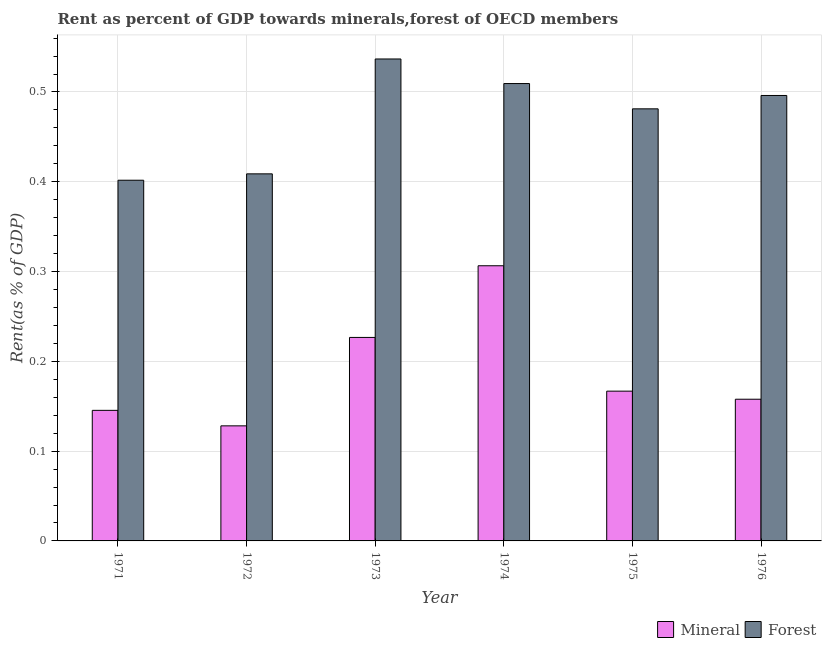How many different coloured bars are there?
Give a very brief answer. 2. Are the number of bars on each tick of the X-axis equal?
Provide a short and direct response. Yes. How many bars are there on the 2nd tick from the right?
Make the answer very short. 2. What is the label of the 5th group of bars from the left?
Your response must be concise. 1975. What is the mineral rent in 1971?
Keep it short and to the point. 0.15. Across all years, what is the maximum mineral rent?
Offer a very short reply. 0.31. Across all years, what is the minimum mineral rent?
Ensure brevity in your answer.  0.13. In which year was the mineral rent maximum?
Your response must be concise. 1974. What is the total mineral rent in the graph?
Provide a succinct answer. 1.13. What is the difference between the forest rent in 1973 and that in 1975?
Provide a short and direct response. 0.06. What is the difference between the forest rent in 1972 and the mineral rent in 1976?
Make the answer very short. -0.09. What is the average forest rent per year?
Ensure brevity in your answer.  0.47. In the year 1975, what is the difference between the forest rent and mineral rent?
Provide a short and direct response. 0. In how many years, is the mineral rent greater than 0.16 %?
Make the answer very short. 3. What is the ratio of the mineral rent in 1971 to that in 1974?
Your response must be concise. 0.47. What is the difference between the highest and the second highest mineral rent?
Offer a very short reply. 0.08. What is the difference between the highest and the lowest forest rent?
Provide a succinct answer. 0.14. What does the 1st bar from the left in 1973 represents?
Provide a succinct answer. Mineral. What does the 2nd bar from the right in 1976 represents?
Keep it short and to the point. Mineral. Are all the bars in the graph horizontal?
Make the answer very short. No. How many years are there in the graph?
Offer a very short reply. 6. What is the difference between two consecutive major ticks on the Y-axis?
Ensure brevity in your answer.  0.1. Does the graph contain grids?
Give a very brief answer. Yes. Where does the legend appear in the graph?
Provide a succinct answer. Bottom right. How many legend labels are there?
Provide a short and direct response. 2. How are the legend labels stacked?
Your answer should be compact. Horizontal. What is the title of the graph?
Provide a succinct answer. Rent as percent of GDP towards minerals,forest of OECD members. What is the label or title of the Y-axis?
Ensure brevity in your answer.  Rent(as % of GDP). What is the Rent(as % of GDP) in Mineral in 1971?
Make the answer very short. 0.15. What is the Rent(as % of GDP) of Forest in 1971?
Provide a short and direct response. 0.4. What is the Rent(as % of GDP) in Mineral in 1972?
Your answer should be compact. 0.13. What is the Rent(as % of GDP) in Forest in 1972?
Offer a terse response. 0.41. What is the Rent(as % of GDP) in Mineral in 1973?
Your answer should be compact. 0.23. What is the Rent(as % of GDP) in Forest in 1973?
Your answer should be compact. 0.54. What is the Rent(as % of GDP) in Mineral in 1974?
Provide a succinct answer. 0.31. What is the Rent(as % of GDP) in Forest in 1974?
Offer a very short reply. 0.51. What is the Rent(as % of GDP) in Mineral in 1975?
Your answer should be very brief. 0.17. What is the Rent(as % of GDP) in Forest in 1975?
Provide a succinct answer. 0.48. What is the Rent(as % of GDP) of Mineral in 1976?
Your answer should be very brief. 0.16. What is the Rent(as % of GDP) in Forest in 1976?
Make the answer very short. 0.5. Across all years, what is the maximum Rent(as % of GDP) in Mineral?
Your response must be concise. 0.31. Across all years, what is the maximum Rent(as % of GDP) in Forest?
Offer a very short reply. 0.54. Across all years, what is the minimum Rent(as % of GDP) of Mineral?
Provide a succinct answer. 0.13. Across all years, what is the minimum Rent(as % of GDP) of Forest?
Give a very brief answer. 0.4. What is the total Rent(as % of GDP) in Mineral in the graph?
Your response must be concise. 1.13. What is the total Rent(as % of GDP) in Forest in the graph?
Your answer should be compact. 2.83. What is the difference between the Rent(as % of GDP) of Mineral in 1971 and that in 1972?
Your answer should be compact. 0.02. What is the difference between the Rent(as % of GDP) in Forest in 1971 and that in 1972?
Keep it short and to the point. -0.01. What is the difference between the Rent(as % of GDP) of Mineral in 1971 and that in 1973?
Ensure brevity in your answer.  -0.08. What is the difference between the Rent(as % of GDP) in Forest in 1971 and that in 1973?
Offer a very short reply. -0.14. What is the difference between the Rent(as % of GDP) in Mineral in 1971 and that in 1974?
Provide a short and direct response. -0.16. What is the difference between the Rent(as % of GDP) in Forest in 1971 and that in 1974?
Offer a very short reply. -0.11. What is the difference between the Rent(as % of GDP) of Mineral in 1971 and that in 1975?
Your response must be concise. -0.02. What is the difference between the Rent(as % of GDP) in Forest in 1971 and that in 1975?
Provide a succinct answer. -0.08. What is the difference between the Rent(as % of GDP) of Mineral in 1971 and that in 1976?
Your response must be concise. -0.01. What is the difference between the Rent(as % of GDP) of Forest in 1971 and that in 1976?
Your answer should be compact. -0.09. What is the difference between the Rent(as % of GDP) of Mineral in 1972 and that in 1973?
Offer a terse response. -0.1. What is the difference between the Rent(as % of GDP) of Forest in 1972 and that in 1973?
Your answer should be very brief. -0.13. What is the difference between the Rent(as % of GDP) of Mineral in 1972 and that in 1974?
Ensure brevity in your answer.  -0.18. What is the difference between the Rent(as % of GDP) of Forest in 1972 and that in 1974?
Ensure brevity in your answer.  -0.1. What is the difference between the Rent(as % of GDP) of Mineral in 1972 and that in 1975?
Your answer should be very brief. -0.04. What is the difference between the Rent(as % of GDP) of Forest in 1972 and that in 1975?
Provide a short and direct response. -0.07. What is the difference between the Rent(as % of GDP) in Mineral in 1972 and that in 1976?
Provide a succinct answer. -0.03. What is the difference between the Rent(as % of GDP) in Forest in 1972 and that in 1976?
Provide a short and direct response. -0.09. What is the difference between the Rent(as % of GDP) in Mineral in 1973 and that in 1974?
Give a very brief answer. -0.08. What is the difference between the Rent(as % of GDP) in Forest in 1973 and that in 1974?
Your answer should be compact. 0.03. What is the difference between the Rent(as % of GDP) of Mineral in 1973 and that in 1975?
Provide a short and direct response. 0.06. What is the difference between the Rent(as % of GDP) in Forest in 1973 and that in 1975?
Your answer should be compact. 0.06. What is the difference between the Rent(as % of GDP) in Mineral in 1973 and that in 1976?
Keep it short and to the point. 0.07. What is the difference between the Rent(as % of GDP) in Forest in 1973 and that in 1976?
Your response must be concise. 0.04. What is the difference between the Rent(as % of GDP) in Mineral in 1974 and that in 1975?
Offer a terse response. 0.14. What is the difference between the Rent(as % of GDP) of Forest in 1974 and that in 1975?
Provide a short and direct response. 0.03. What is the difference between the Rent(as % of GDP) in Mineral in 1974 and that in 1976?
Provide a succinct answer. 0.15. What is the difference between the Rent(as % of GDP) in Forest in 1974 and that in 1976?
Ensure brevity in your answer.  0.01. What is the difference between the Rent(as % of GDP) of Mineral in 1975 and that in 1976?
Provide a succinct answer. 0.01. What is the difference between the Rent(as % of GDP) of Forest in 1975 and that in 1976?
Provide a succinct answer. -0.01. What is the difference between the Rent(as % of GDP) in Mineral in 1971 and the Rent(as % of GDP) in Forest in 1972?
Your answer should be compact. -0.26. What is the difference between the Rent(as % of GDP) of Mineral in 1971 and the Rent(as % of GDP) of Forest in 1973?
Ensure brevity in your answer.  -0.39. What is the difference between the Rent(as % of GDP) in Mineral in 1971 and the Rent(as % of GDP) in Forest in 1974?
Give a very brief answer. -0.36. What is the difference between the Rent(as % of GDP) of Mineral in 1971 and the Rent(as % of GDP) of Forest in 1975?
Your response must be concise. -0.34. What is the difference between the Rent(as % of GDP) of Mineral in 1971 and the Rent(as % of GDP) of Forest in 1976?
Give a very brief answer. -0.35. What is the difference between the Rent(as % of GDP) of Mineral in 1972 and the Rent(as % of GDP) of Forest in 1973?
Make the answer very short. -0.41. What is the difference between the Rent(as % of GDP) of Mineral in 1972 and the Rent(as % of GDP) of Forest in 1974?
Make the answer very short. -0.38. What is the difference between the Rent(as % of GDP) in Mineral in 1972 and the Rent(as % of GDP) in Forest in 1975?
Keep it short and to the point. -0.35. What is the difference between the Rent(as % of GDP) in Mineral in 1972 and the Rent(as % of GDP) in Forest in 1976?
Give a very brief answer. -0.37. What is the difference between the Rent(as % of GDP) of Mineral in 1973 and the Rent(as % of GDP) of Forest in 1974?
Give a very brief answer. -0.28. What is the difference between the Rent(as % of GDP) in Mineral in 1973 and the Rent(as % of GDP) in Forest in 1975?
Offer a very short reply. -0.25. What is the difference between the Rent(as % of GDP) of Mineral in 1973 and the Rent(as % of GDP) of Forest in 1976?
Keep it short and to the point. -0.27. What is the difference between the Rent(as % of GDP) of Mineral in 1974 and the Rent(as % of GDP) of Forest in 1975?
Your answer should be compact. -0.17. What is the difference between the Rent(as % of GDP) of Mineral in 1974 and the Rent(as % of GDP) of Forest in 1976?
Make the answer very short. -0.19. What is the difference between the Rent(as % of GDP) in Mineral in 1975 and the Rent(as % of GDP) in Forest in 1976?
Offer a very short reply. -0.33. What is the average Rent(as % of GDP) in Mineral per year?
Your answer should be very brief. 0.19. What is the average Rent(as % of GDP) in Forest per year?
Ensure brevity in your answer.  0.47. In the year 1971, what is the difference between the Rent(as % of GDP) in Mineral and Rent(as % of GDP) in Forest?
Offer a very short reply. -0.26. In the year 1972, what is the difference between the Rent(as % of GDP) of Mineral and Rent(as % of GDP) of Forest?
Offer a terse response. -0.28. In the year 1973, what is the difference between the Rent(as % of GDP) of Mineral and Rent(as % of GDP) of Forest?
Offer a very short reply. -0.31. In the year 1974, what is the difference between the Rent(as % of GDP) in Mineral and Rent(as % of GDP) in Forest?
Provide a short and direct response. -0.2. In the year 1975, what is the difference between the Rent(as % of GDP) in Mineral and Rent(as % of GDP) in Forest?
Offer a terse response. -0.31. In the year 1976, what is the difference between the Rent(as % of GDP) of Mineral and Rent(as % of GDP) of Forest?
Provide a succinct answer. -0.34. What is the ratio of the Rent(as % of GDP) of Mineral in 1971 to that in 1972?
Make the answer very short. 1.13. What is the ratio of the Rent(as % of GDP) in Forest in 1971 to that in 1972?
Provide a short and direct response. 0.98. What is the ratio of the Rent(as % of GDP) in Mineral in 1971 to that in 1973?
Keep it short and to the point. 0.64. What is the ratio of the Rent(as % of GDP) in Forest in 1971 to that in 1973?
Provide a succinct answer. 0.75. What is the ratio of the Rent(as % of GDP) in Mineral in 1971 to that in 1974?
Offer a terse response. 0.47. What is the ratio of the Rent(as % of GDP) of Forest in 1971 to that in 1974?
Make the answer very short. 0.79. What is the ratio of the Rent(as % of GDP) of Mineral in 1971 to that in 1975?
Keep it short and to the point. 0.87. What is the ratio of the Rent(as % of GDP) in Forest in 1971 to that in 1975?
Offer a very short reply. 0.83. What is the ratio of the Rent(as % of GDP) in Mineral in 1971 to that in 1976?
Provide a succinct answer. 0.92. What is the ratio of the Rent(as % of GDP) in Forest in 1971 to that in 1976?
Make the answer very short. 0.81. What is the ratio of the Rent(as % of GDP) of Mineral in 1972 to that in 1973?
Keep it short and to the point. 0.57. What is the ratio of the Rent(as % of GDP) of Forest in 1972 to that in 1973?
Give a very brief answer. 0.76. What is the ratio of the Rent(as % of GDP) in Mineral in 1972 to that in 1974?
Ensure brevity in your answer.  0.42. What is the ratio of the Rent(as % of GDP) of Forest in 1972 to that in 1974?
Give a very brief answer. 0.8. What is the ratio of the Rent(as % of GDP) of Mineral in 1972 to that in 1975?
Your answer should be compact. 0.77. What is the ratio of the Rent(as % of GDP) in Forest in 1972 to that in 1975?
Offer a terse response. 0.85. What is the ratio of the Rent(as % of GDP) in Mineral in 1972 to that in 1976?
Offer a very short reply. 0.81. What is the ratio of the Rent(as % of GDP) of Forest in 1972 to that in 1976?
Offer a terse response. 0.82. What is the ratio of the Rent(as % of GDP) in Mineral in 1973 to that in 1974?
Offer a terse response. 0.74. What is the ratio of the Rent(as % of GDP) in Forest in 1973 to that in 1974?
Your answer should be compact. 1.05. What is the ratio of the Rent(as % of GDP) in Mineral in 1973 to that in 1975?
Make the answer very short. 1.36. What is the ratio of the Rent(as % of GDP) of Forest in 1973 to that in 1975?
Your answer should be compact. 1.12. What is the ratio of the Rent(as % of GDP) in Mineral in 1973 to that in 1976?
Ensure brevity in your answer.  1.44. What is the ratio of the Rent(as % of GDP) in Forest in 1973 to that in 1976?
Offer a very short reply. 1.08. What is the ratio of the Rent(as % of GDP) of Mineral in 1974 to that in 1975?
Your answer should be compact. 1.84. What is the ratio of the Rent(as % of GDP) of Forest in 1974 to that in 1975?
Your response must be concise. 1.06. What is the ratio of the Rent(as % of GDP) of Mineral in 1974 to that in 1976?
Make the answer very short. 1.94. What is the ratio of the Rent(as % of GDP) of Forest in 1974 to that in 1976?
Offer a terse response. 1.03. What is the ratio of the Rent(as % of GDP) in Mineral in 1975 to that in 1976?
Ensure brevity in your answer.  1.06. What is the difference between the highest and the second highest Rent(as % of GDP) of Mineral?
Give a very brief answer. 0.08. What is the difference between the highest and the second highest Rent(as % of GDP) of Forest?
Keep it short and to the point. 0.03. What is the difference between the highest and the lowest Rent(as % of GDP) in Mineral?
Provide a succinct answer. 0.18. What is the difference between the highest and the lowest Rent(as % of GDP) of Forest?
Your answer should be very brief. 0.14. 